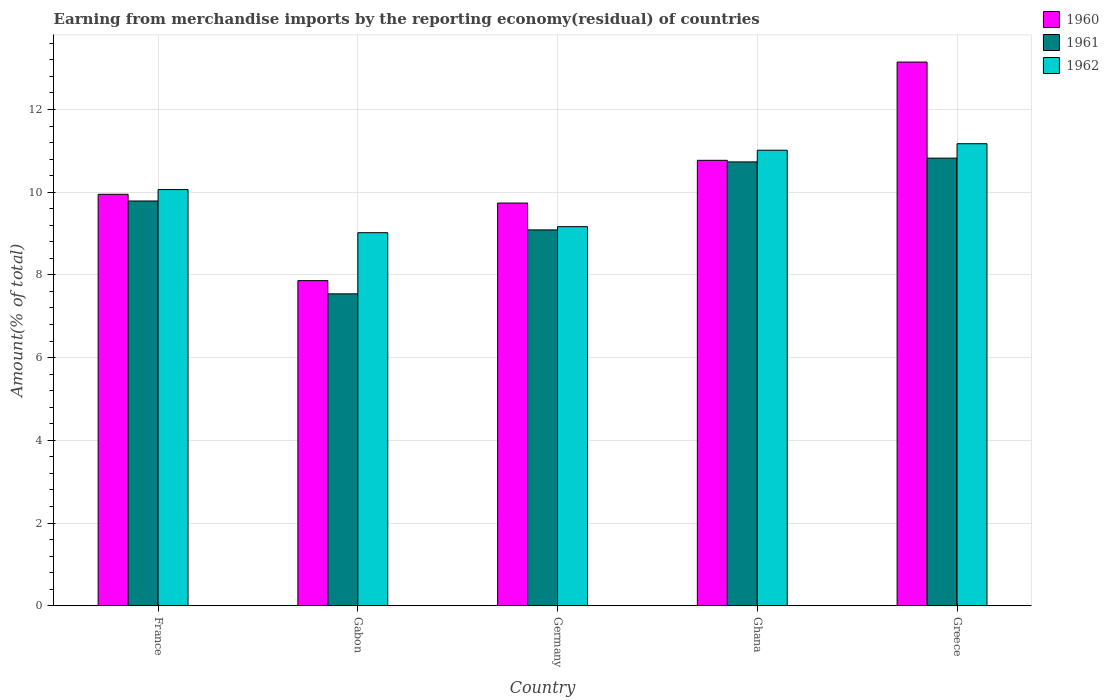Are the number of bars per tick equal to the number of legend labels?
Make the answer very short. Yes. How many bars are there on the 2nd tick from the left?
Provide a succinct answer. 3. How many bars are there on the 3rd tick from the right?
Offer a terse response. 3. What is the label of the 1st group of bars from the left?
Keep it short and to the point. France. What is the percentage of amount earned from merchandise imports in 1962 in Greece?
Your response must be concise. 11.17. Across all countries, what is the maximum percentage of amount earned from merchandise imports in 1962?
Make the answer very short. 11.17. Across all countries, what is the minimum percentage of amount earned from merchandise imports in 1961?
Your response must be concise. 7.54. In which country was the percentage of amount earned from merchandise imports in 1961 maximum?
Provide a short and direct response. Greece. In which country was the percentage of amount earned from merchandise imports in 1961 minimum?
Your answer should be very brief. Gabon. What is the total percentage of amount earned from merchandise imports in 1961 in the graph?
Give a very brief answer. 47.97. What is the difference between the percentage of amount earned from merchandise imports in 1962 in Germany and that in Greece?
Ensure brevity in your answer.  -2.01. What is the difference between the percentage of amount earned from merchandise imports in 1961 in Greece and the percentage of amount earned from merchandise imports in 1960 in France?
Your response must be concise. 0.87. What is the average percentage of amount earned from merchandise imports in 1960 per country?
Your answer should be compact. 10.29. What is the difference between the percentage of amount earned from merchandise imports of/in 1961 and percentage of amount earned from merchandise imports of/in 1960 in Greece?
Offer a very short reply. -2.32. What is the ratio of the percentage of amount earned from merchandise imports in 1960 in Gabon to that in Germany?
Give a very brief answer. 0.81. Is the difference between the percentage of amount earned from merchandise imports in 1961 in France and Greece greater than the difference between the percentage of amount earned from merchandise imports in 1960 in France and Greece?
Offer a terse response. Yes. What is the difference between the highest and the second highest percentage of amount earned from merchandise imports in 1961?
Offer a terse response. -1.04. What is the difference between the highest and the lowest percentage of amount earned from merchandise imports in 1960?
Your answer should be very brief. 5.28. Is it the case that in every country, the sum of the percentage of amount earned from merchandise imports in 1960 and percentage of amount earned from merchandise imports in 1962 is greater than the percentage of amount earned from merchandise imports in 1961?
Keep it short and to the point. Yes. How many bars are there?
Provide a succinct answer. 15. Are all the bars in the graph horizontal?
Offer a terse response. No. How many countries are there in the graph?
Your answer should be compact. 5. Does the graph contain any zero values?
Ensure brevity in your answer.  No. Where does the legend appear in the graph?
Your response must be concise. Top right. How many legend labels are there?
Your answer should be compact. 3. What is the title of the graph?
Your response must be concise. Earning from merchandise imports by the reporting economy(residual) of countries. Does "1995" appear as one of the legend labels in the graph?
Ensure brevity in your answer.  No. What is the label or title of the Y-axis?
Offer a very short reply. Amount(% of total). What is the Amount(% of total) in 1960 in France?
Give a very brief answer. 9.95. What is the Amount(% of total) of 1961 in France?
Offer a terse response. 9.79. What is the Amount(% of total) in 1962 in France?
Your answer should be compact. 10.06. What is the Amount(% of total) in 1960 in Gabon?
Give a very brief answer. 7.86. What is the Amount(% of total) in 1961 in Gabon?
Keep it short and to the point. 7.54. What is the Amount(% of total) in 1962 in Gabon?
Provide a succinct answer. 9.02. What is the Amount(% of total) of 1960 in Germany?
Keep it short and to the point. 9.74. What is the Amount(% of total) of 1961 in Germany?
Keep it short and to the point. 9.09. What is the Amount(% of total) in 1962 in Germany?
Provide a succinct answer. 9.17. What is the Amount(% of total) in 1960 in Ghana?
Keep it short and to the point. 10.77. What is the Amount(% of total) in 1961 in Ghana?
Provide a succinct answer. 10.73. What is the Amount(% of total) in 1962 in Ghana?
Offer a very short reply. 11.01. What is the Amount(% of total) in 1960 in Greece?
Offer a very short reply. 13.15. What is the Amount(% of total) of 1961 in Greece?
Give a very brief answer. 10.82. What is the Amount(% of total) of 1962 in Greece?
Offer a very short reply. 11.17. Across all countries, what is the maximum Amount(% of total) of 1960?
Offer a very short reply. 13.15. Across all countries, what is the maximum Amount(% of total) of 1961?
Offer a terse response. 10.82. Across all countries, what is the maximum Amount(% of total) of 1962?
Ensure brevity in your answer.  11.17. Across all countries, what is the minimum Amount(% of total) of 1960?
Offer a very short reply. 7.86. Across all countries, what is the minimum Amount(% of total) in 1961?
Offer a very short reply. 7.54. Across all countries, what is the minimum Amount(% of total) in 1962?
Your answer should be very brief. 9.02. What is the total Amount(% of total) of 1960 in the graph?
Offer a terse response. 51.46. What is the total Amount(% of total) in 1961 in the graph?
Your answer should be very brief. 47.97. What is the total Amount(% of total) of 1962 in the graph?
Your answer should be compact. 50.44. What is the difference between the Amount(% of total) in 1960 in France and that in Gabon?
Provide a short and direct response. 2.09. What is the difference between the Amount(% of total) in 1961 in France and that in Gabon?
Keep it short and to the point. 2.25. What is the difference between the Amount(% of total) in 1962 in France and that in Gabon?
Provide a short and direct response. 1.04. What is the difference between the Amount(% of total) of 1960 in France and that in Germany?
Offer a very short reply. 0.21. What is the difference between the Amount(% of total) of 1961 in France and that in Germany?
Your answer should be compact. 0.7. What is the difference between the Amount(% of total) in 1962 in France and that in Germany?
Provide a succinct answer. 0.9. What is the difference between the Amount(% of total) in 1960 in France and that in Ghana?
Provide a short and direct response. -0.82. What is the difference between the Amount(% of total) in 1961 in France and that in Ghana?
Provide a succinct answer. -0.94. What is the difference between the Amount(% of total) in 1962 in France and that in Ghana?
Your response must be concise. -0.95. What is the difference between the Amount(% of total) in 1960 in France and that in Greece?
Offer a very short reply. -3.2. What is the difference between the Amount(% of total) of 1961 in France and that in Greece?
Provide a succinct answer. -1.04. What is the difference between the Amount(% of total) of 1962 in France and that in Greece?
Your response must be concise. -1.11. What is the difference between the Amount(% of total) in 1960 in Gabon and that in Germany?
Offer a very short reply. -1.88. What is the difference between the Amount(% of total) of 1961 in Gabon and that in Germany?
Offer a terse response. -1.55. What is the difference between the Amount(% of total) of 1962 in Gabon and that in Germany?
Your response must be concise. -0.15. What is the difference between the Amount(% of total) in 1960 in Gabon and that in Ghana?
Ensure brevity in your answer.  -2.91. What is the difference between the Amount(% of total) in 1961 in Gabon and that in Ghana?
Make the answer very short. -3.19. What is the difference between the Amount(% of total) in 1962 in Gabon and that in Ghana?
Your answer should be compact. -1.99. What is the difference between the Amount(% of total) in 1960 in Gabon and that in Greece?
Keep it short and to the point. -5.28. What is the difference between the Amount(% of total) in 1961 in Gabon and that in Greece?
Provide a short and direct response. -3.28. What is the difference between the Amount(% of total) in 1962 in Gabon and that in Greece?
Your answer should be very brief. -2.15. What is the difference between the Amount(% of total) in 1960 in Germany and that in Ghana?
Your answer should be compact. -1.03. What is the difference between the Amount(% of total) of 1961 in Germany and that in Ghana?
Offer a very short reply. -1.64. What is the difference between the Amount(% of total) of 1962 in Germany and that in Ghana?
Provide a short and direct response. -1.85. What is the difference between the Amount(% of total) in 1960 in Germany and that in Greece?
Your answer should be very brief. -3.41. What is the difference between the Amount(% of total) in 1961 in Germany and that in Greece?
Ensure brevity in your answer.  -1.74. What is the difference between the Amount(% of total) in 1962 in Germany and that in Greece?
Offer a very short reply. -2.01. What is the difference between the Amount(% of total) of 1960 in Ghana and that in Greece?
Give a very brief answer. -2.38. What is the difference between the Amount(% of total) in 1961 in Ghana and that in Greece?
Offer a terse response. -0.09. What is the difference between the Amount(% of total) in 1962 in Ghana and that in Greece?
Ensure brevity in your answer.  -0.16. What is the difference between the Amount(% of total) in 1960 in France and the Amount(% of total) in 1961 in Gabon?
Offer a very short reply. 2.41. What is the difference between the Amount(% of total) in 1960 in France and the Amount(% of total) in 1962 in Gabon?
Provide a short and direct response. 0.93. What is the difference between the Amount(% of total) of 1961 in France and the Amount(% of total) of 1962 in Gabon?
Provide a short and direct response. 0.77. What is the difference between the Amount(% of total) in 1960 in France and the Amount(% of total) in 1961 in Germany?
Make the answer very short. 0.86. What is the difference between the Amount(% of total) of 1960 in France and the Amount(% of total) of 1962 in Germany?
Make the answer very short. 0.78. What is the difference between the Amount(% of total) in 1961 in France and the Amount(% of total) in 1962 in Germany?
Make the answer very short. 0.62. What is the difference between the Amount(% of total) of 1960 in France and the Amount(% of total) of 1961 in Ghana?
Your answer should be compact. -0.78. What is the difference between the Amount(% of total) of 1960 in France and the Amount(% of total) of 1962 in Ghana?
Your answer should be compact. -1.07. What is the difference between the Amount(% of total) in 1961 in France and the Amount(% of total) in 1962 in Ghana?
Give a very brief answer. -1.23. What is the difference between the Amount(% of total) in 1960 in France and the Amount(% of total) in 1961 in Greece?
Make the answer very short. -0.87. What is the difference between the Amount(% of total) of 1960 in France and the Amount(% of total) of 1962 in Greece?
Provide a succinct answer. -1.22. What is the difference between the Amount(% of total) in 1961 in France and the Amount(% of total) in 1962 in Greece?
Provide a short and direct response. -1.38. What is the difference between the Amount(% of total) of 1960 in Gabon and the Amount(% of total) of 1961 in Germany?
Your answer should be compact. -1.23. What is the difference between the Amount(% of total) in 1960 in Gabon and the Amount(% of total) in 1962 in Germany?
Your answer should be compact. -1.3. What is the difference between the Amount(% of total) in 1961 in Gabon and the Amount(% of total) in 1962 in Germany?
Your answer should be very brief. -1.62. What is the difference between the Amount(% of total) of 1960 in Gabon and the Amount(% of total) of 1961 in Ghana?
Offer a very short reply. -2.87. What is the difference between the Amount(% of total) of 1960 in Gabon and the Amount(% of total) of 1962 in Ghana?
Give a very brief answer. -3.15. What is the difference between the Amount(% of total) of 1961 in Gabon and the Amount(% of total) of 1962 in Ghana?
Provide a short and direct response. -3.47. What is the difference between the Amount(% of total) in 1960 in Gabon and the Amount(% of total) in 1961 in Greece?
Your answer should be compact. -2.96. What is the difference between the Amount(% of total) of 1960 in Gabon and the Amount(% of total) of 1962 in Greece?
Ensure brevity in your answer.  -3.31. What is the difference between the Amount(% of total) of 1961 in Gabon and the Amount(% of total) of 1962 in Greece?
Make the answer very short. -3.63. What is the difference between the Amount(% of total) of 1960 in Germany and the Amount(% of total) of 1961 in Ghana?
Provide a succinct answer. -0.99. What is the difference between the Amount(% of total) in 1960 in Germany and the Amount(% of total) in 1962 in Ghana?
Provide a succinct answer. -1.28. What is the difference between the Amount(% of total) in 1961 in Germany and the Amount(% of total) in 1962 in Ghana?
Offer a terse response. -1.93. What is the difference between the Amount(% of total) in 1960 in Germany and the Amount(% of total) in 1961 in Greece?
Ensure brevity in your answer.  -1.09. What is the difference between the Amount(% of total) of 1960 in Germany and the Amount(% of total) of 1962 in Greece?
Your response must be concise. -1.43. What is the difference between the Amount(% of total) in 1961 in Germany and the Amount(% of total) in 1962 in Greece?
Give a very brief answer. -2.08. What is the difference between the Amount(% of total) in 1960 in Ghana and the Amount(% of total) in 1961 in Greece?
Provide a short and direct response. -0.05. What is the difference between the Amount(% of total) of 1960 in Ghana and the Amount(% of total) of 1962 in Greece?
Offer a very short reply. -0.4. What is the difference between the Amount(% of total) of 1961 in Ghana and the Amount(% of total) of 1962 in Greece?
Offer a very short reply. -0.44. What is the average Amount(% of total) in 1960 per country?
Your answer should be very brief. 10.29. What is the average Amount(% of total) of 1961 per country?
Offer a terse response. 9.59. What is the average Amount(% of total) of 1962 per country?
Offer a very short reply. 10.09. What is the difference between the Amount(% of total) in 1960 and Amount(% of total) in 1961 in France?
Offer a terse response. 0.16. What is the difference between the Amount(% of total) in 1960 and Amount(% of total) in 1962 in France?
Provide a short and direct response. -0.11. What is the difference between the Amount(% of total) of 1961 and Amount(% of total) of 1962 in France?
Your answer should be compact. -0.28. What is the difference between the Amount(% of total) of 1960 and Amount(% of total) of 1961 in Gabon?
Your answer should be very brief. 0.32. What is the difference between the Amount(% of total) in 1960 and Amount(% of total) in 1962 in Gabon?
Your answer should be compact. -1.16. What is the difference between the Amount(% of total) in 1961 and Amount(% of total) in 1962 in Gabon?
Offer a very short reply. -1.48. What is the difference between the Amount(% of total) in 1960 and Amount(% of total) in 1961 in Germany?
Give a very brief answer. 0.65. What is the difference between the Amount(% of total) in 1960 and Amount(% of total) in 1962 in Germany?
Offer a terse response. 0.57. What is the difference between the Amount(% of total) in 1961 and Amount(% of total) in 1962 in Germany?
Your answer should be compact. -0.08. What is the difference between the Amount(% of total) of 1960 and Amount(% of total) of 1961 in Ghana?
Offer a terse response. 0.04. What is the difference between the Amount(% of total) of 1960 and Amount(% of total) of 1962 in Ghana?
Your response must be concise. -0.24. What is the difference between the Amount(% of total) of 1961 and Amount(% of total) of 1962 in Ghana?
Make the answer very short. -0.28. What is the difference between the Amount(% of total) of 1960 and Amount(% of total) of 1961 in Greece?
Give a very brief answer. 2.32. What is the difference between the Amount(% of total) in 1960 and Amount(% of total) in 1962 in Greece?
Your response must be concise. 1.97. What is the difference between the Amount(% of total) of 1961 and Amount(% of total) of 1962 in Greece?
Offer a terse response. -0.35. What is the ratio of the Amount(% of total) in 1960 in France to that in Gabon?
Provide a succinct answer. 1.27. What is the ratio of the Amount(% of total) of 1961 in France to that in Gabon?
Offer a terse response. 1.3. What is the ratio of the Amount(% of total) of 1962 in France to that in Gabon?
Keep it short and to the point. 1.12. What is the ratio of the Amount(% of total) in 1960 in France to that in Germany?
Offer a terse response. 1.02. What is the ratio of the Amount(% of total) in 1961 in France to that in Germany?
Your response must be concise. 1.08. What is the ratio of the Amount(% of total) in 1962 in France to that in Germany?
Provide a succinct answer. 1.1. What is the ratio of the Amount(% of total) in 1960 in France to that in Ghana?
Offer a terse response. 0.92. What is the ratio of the Amount(% of total) of 1961 in France to that in Ghana?
Offer a terse response. 0.91. What is the ratio of the Amount(% of total) of 1962 in France to that in Ghana?
Ensure brevity in your answer.  0.91. What is the ratio of the Amount(% of total) in 1960 in France to that in Greece?
Your answer should be very brief. 0.76. What is the ratio of the Amount(% of total) of 1961 in France to that in Greece?
Ensure brevity in your answer.  0.9. What is the ratio of the Amount(% of total) of 1962 in France to that in Greece?
Offer a very short reply. 0.9. What is the ratio of the Amount(% of total) in 1960 in Gabon to that in Germany?
Offer a very short reply. 0.81. What is the ratio of the Amount(% of total) of 1961 in Gabon to that in Germany?
Provide a short and direct response. 0.83. What is the ratio of the Amount(% of total) in 1962 in Gabon to that in Germany?
Provide a succinct answer. 0.98. What is the ratio of the Amount(% of total) in 1960 in Gabon to that in Ghana?
Make the answer very short. 0.73. What is the ratio of the Amount(% of total) of 1961 in Gabon to that in Ghana?
Your answer should be compact. 0.7. What is the ratio of the Amount(% of total) in 1962 in Gabon to that in Ghana?
Your answer should be compact. 0.82. What is the ratio of the Amount(% of total) in 1960 in Gabon to that in Greece?
Your answer should be very brief. 0.6. What is the ratio of the Amount(% of total) of 1961 in Gabon to that in Greece?
Provide a short and direct response. 0.7. What is the ratio of the Amount(% of total) of 1962 in Gabon to that in Greece?
Your response must be concise. 0.81. What is the ratio of the Amount(% of total) of 1960 in Germany to that in Ghana?
Your answer should be very brief. 0.9. What is the ratio of the Amount(% of total) of 1961 in Germany to that in Ghana?
Keep it short and to the point. 0.85. What is the ratio of the Amount(% of total) in 1962 in Germany to that in Ghana?
Your answer should be compact. 0.83. What is the ratio of the Amount(% of total) in 1960 in Germany to that in Greece?
Give a very brief answer. 0.74. What is the ratio of the Amount(% of total) in 1961 in Germany to that in Greece?
Provide a short and direct response. 0.84. What is the ratio of the Amount(% of total) of 1962 in Germany to that in Greece?
Offer a terse response. 0.82. What is the ratio of the Amount(% of total) in 1960 in Ghana to that in Greece?
Provide a short and direct response. 0.82. What is the ratio of the Amount(% of total) in 1962 in Ghana to that in Greece?
Your response must be concise. 0.99. What is the difference between the highest and the second highest Amount(% of total) of 1960?
Keep it short and to the point. 2.38. What is the difference between the highest and the second highest Amount(% of total) of 1961?
Ensure brevity in your answer.  0.09. What is the difference between the highest and the second highest Amount(% of total) in 1962?
Your response must be concise. 0.16. What is the difference between the highest and the lowest Amount(% of total) of 1960?
Keep it short and to the point. 5.28. What is the difference between the highest and the lowest Amount(% of total) in 1961?
Your response must be concise. 3.28. What is the difference between the highest and the lowest Amount(% of total) of 1962?
Give a very brief answer. 2.15. 